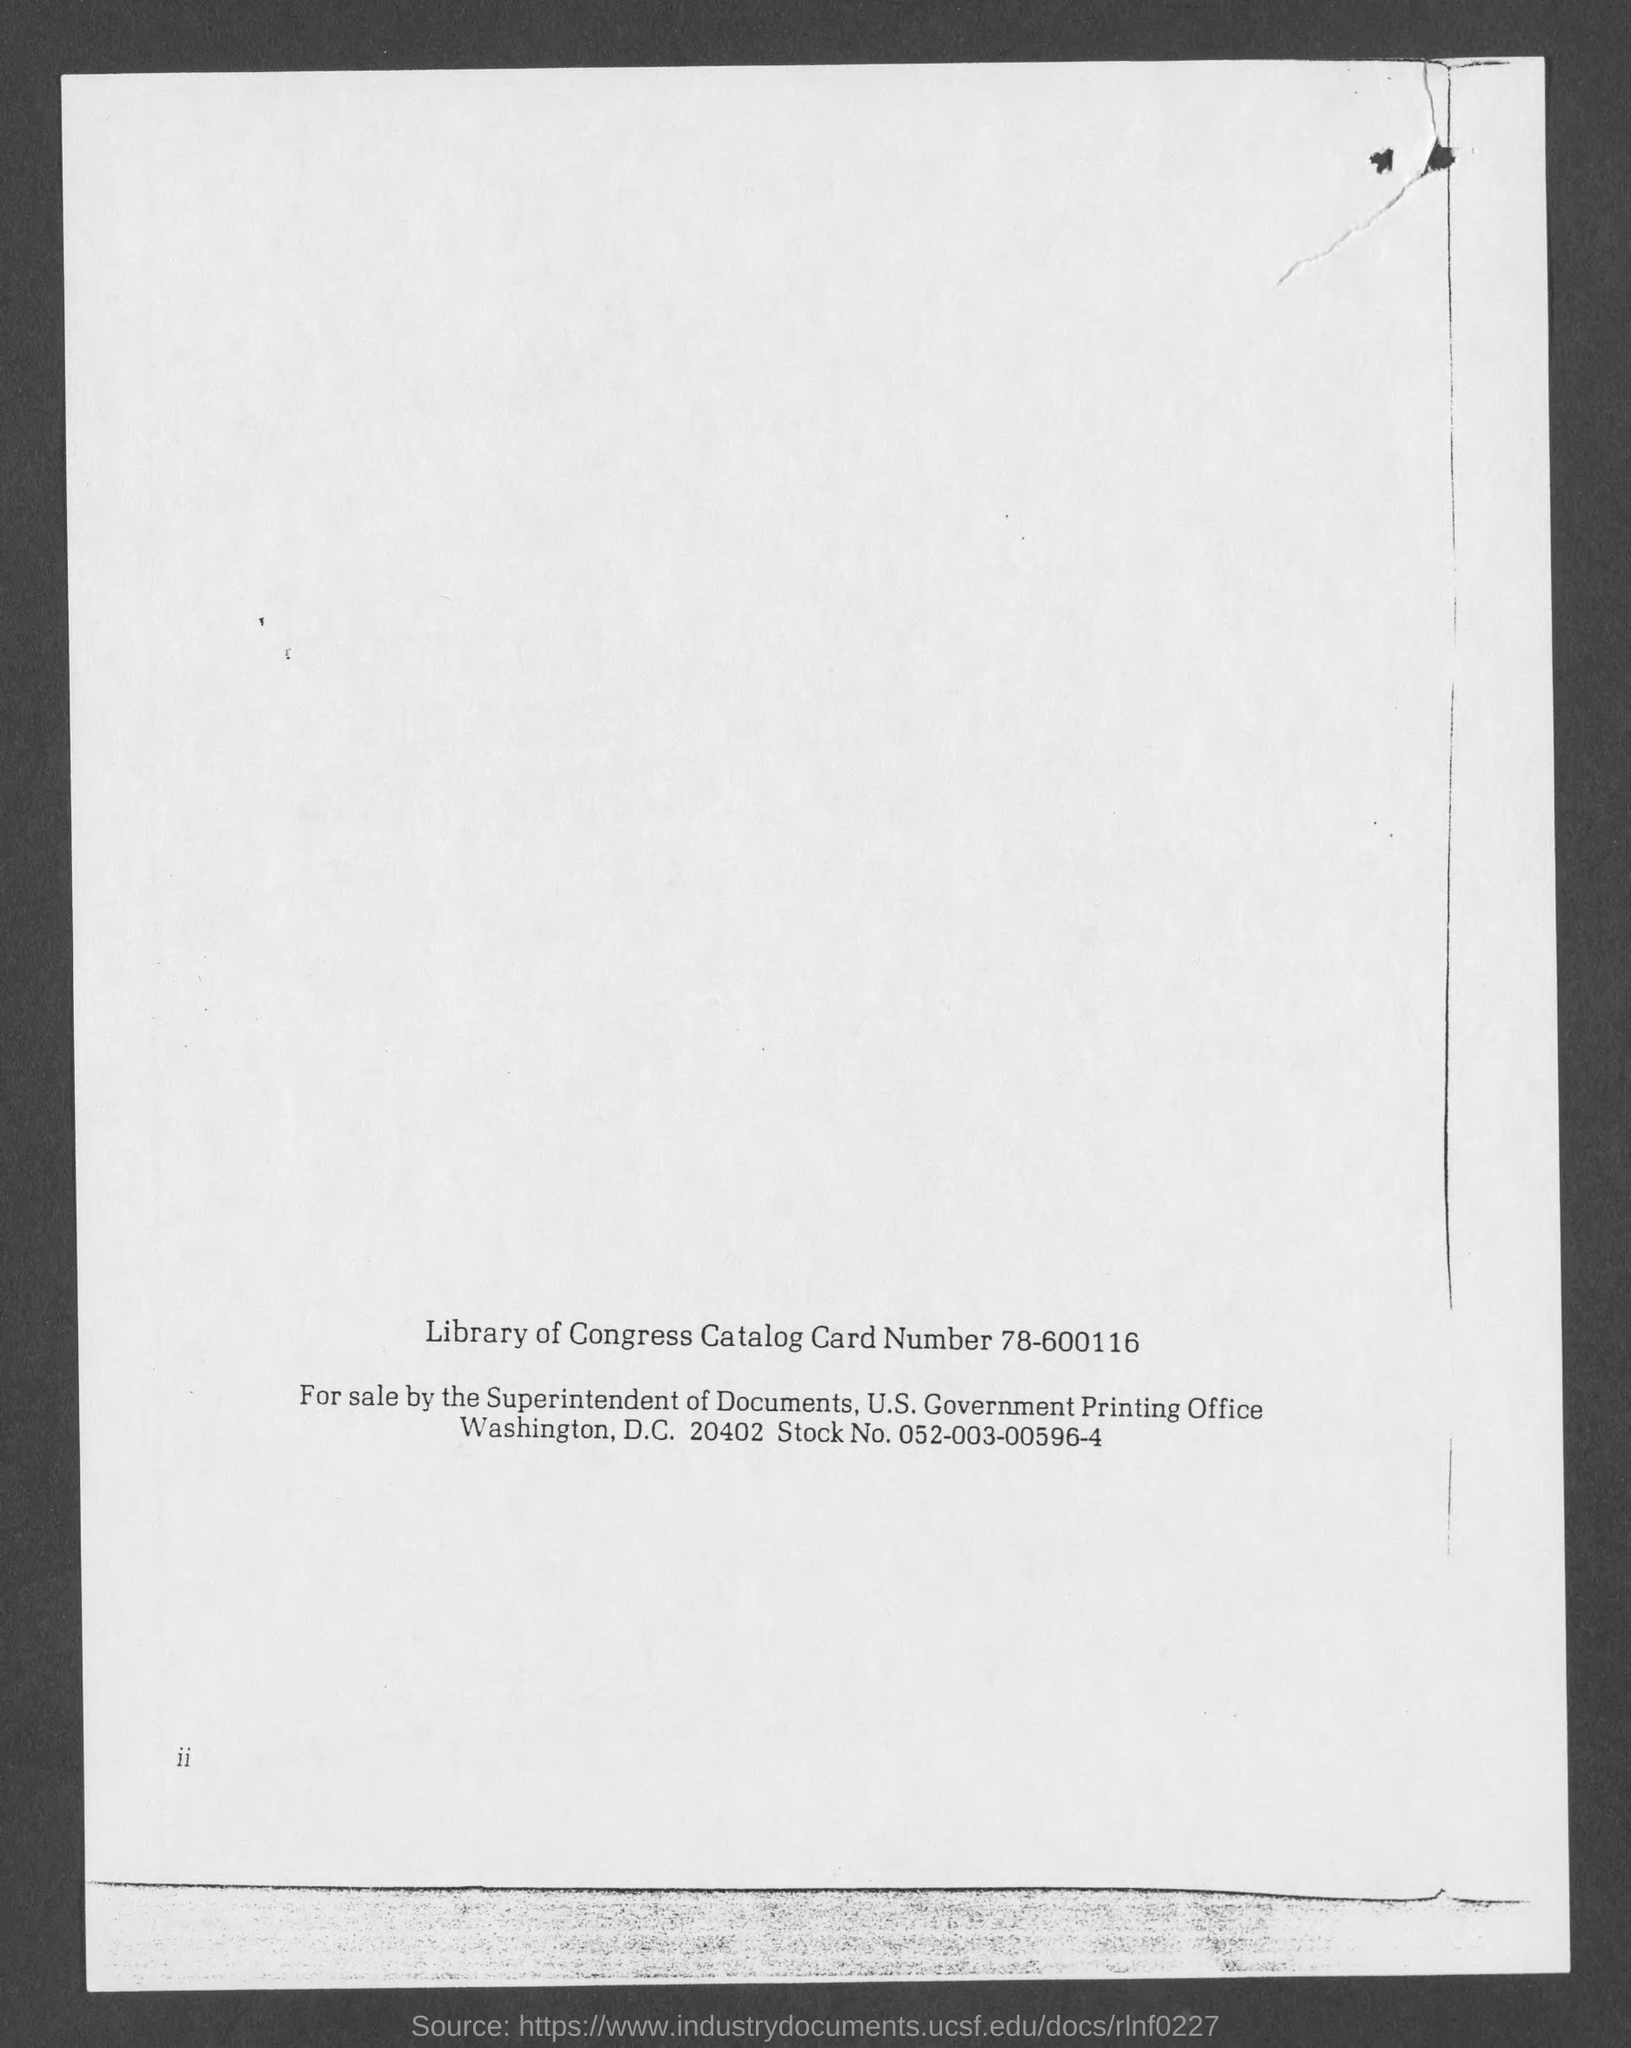Point out several critical features in this image. The Library of Congress catalog card number is 78-600116. The stock number is 052-003-00596-4. 